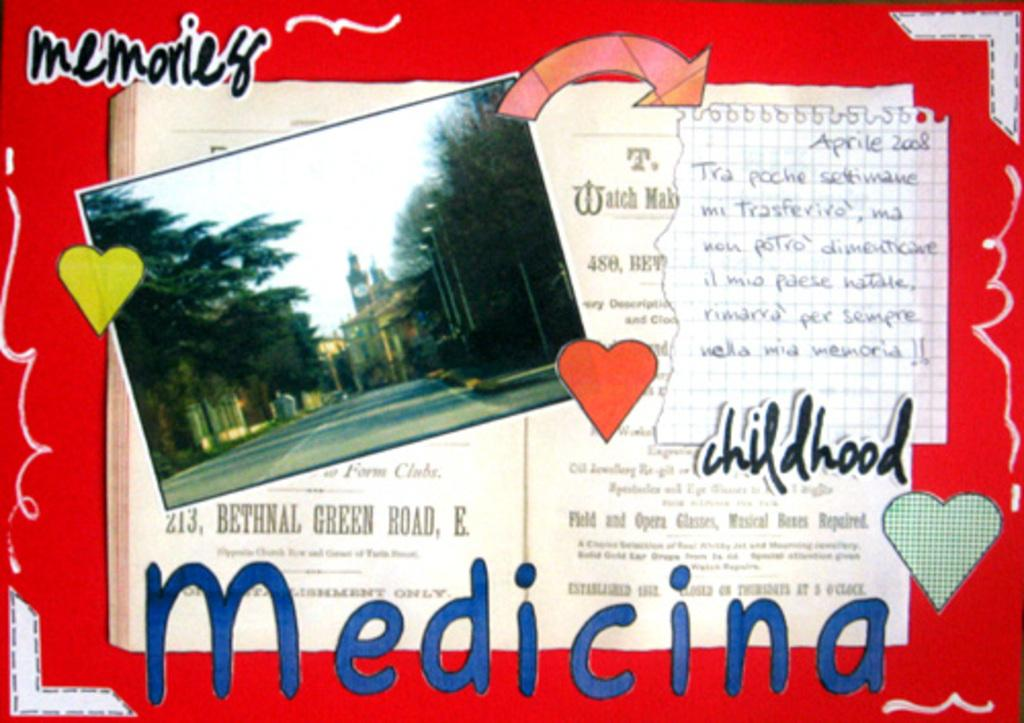Provide a one-sentence caption for the provided image. A postcard in Spanish that shows a picture of a cityscape along with the words "memories", "childhood", and "Medicina". 